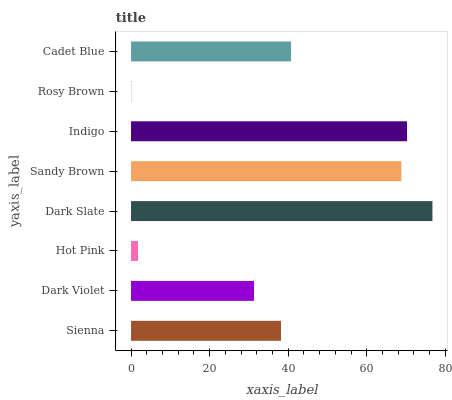Is Rosy Brown the minimum?
Answer yes or no. Yes. Is Dark Slate the maximum?
Answer yes or no. Yes. Is Dark Violet the minimum?
Answer yes or no. No. Is Dark Violet the maximum?
Answer yes or no. No. Is Sienna greater than Dark Violet?
Answer yes or no. Yes. Is Dark Violet less than Sienna?
Answer yes or no. Yes. Is Dark Violet greater than Sienna?
Answer yes or no. No. Is Sienna less than Dark Violet?
Answer yes or no. No. Is Cadet Blue the high median?
Answer yes or no. Yes. Is Sienna the low median?
Answer yes or no. Yes. Is Rosy Brown the high median?
Answer yes or no. No. Is Dark Violet the low median?
Answer yes or no. No. 